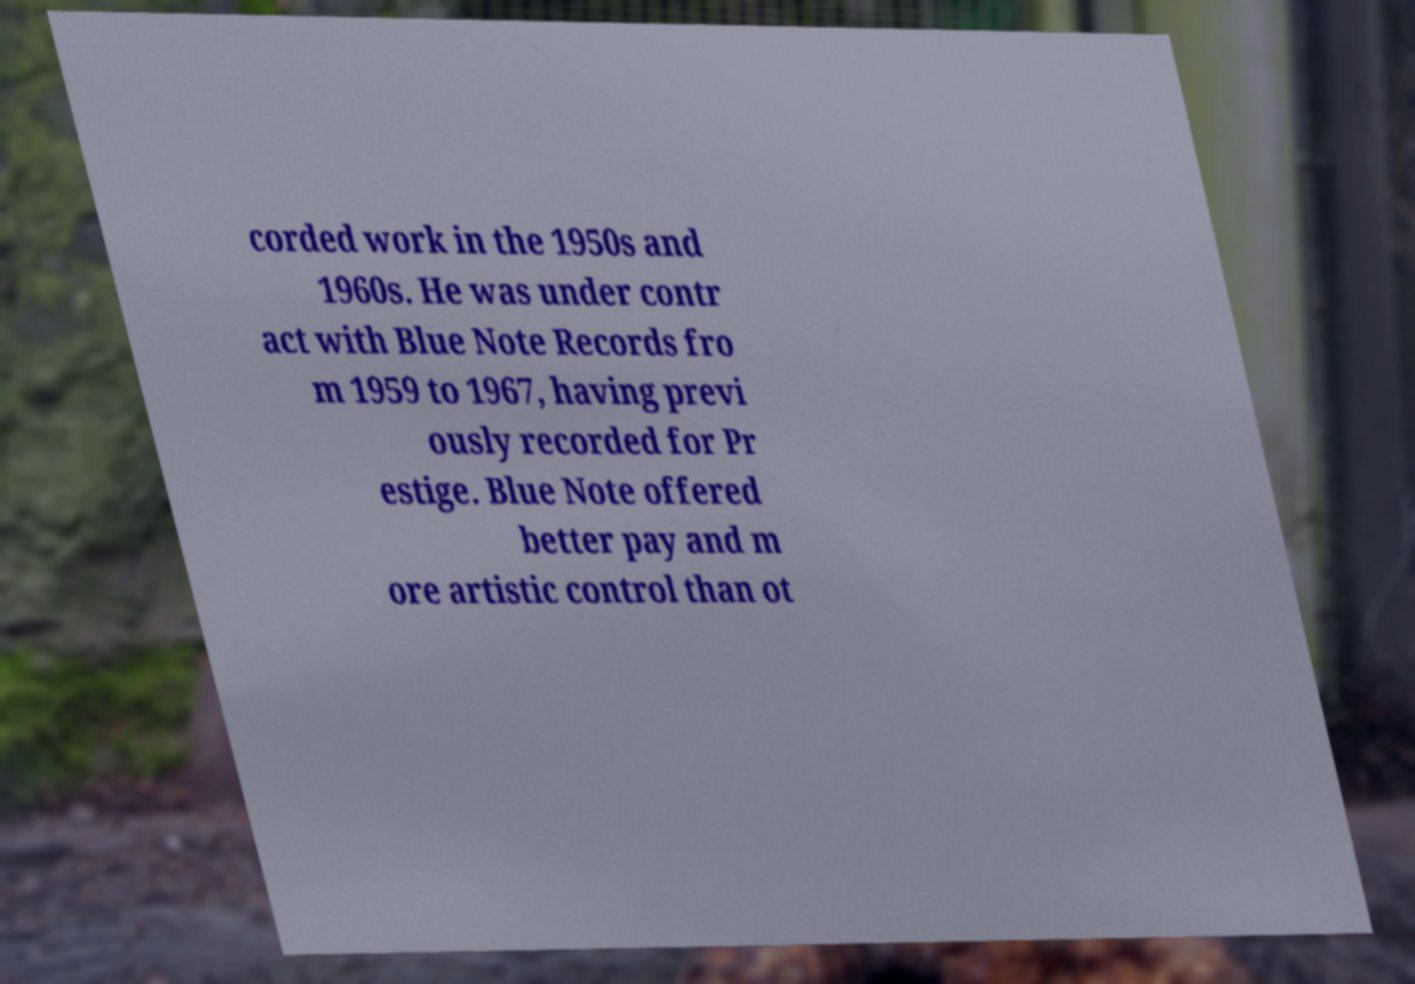For documentation purposes, I need the text within this image transcribed. Could you provide that? corded work in the 1950s and 1960s. He was under contr act with Blue Note Records fro m 1959 to 1967, having previ ously recorded for Pr estige. Blue Note offered better pay and m ore artistic control than ot 